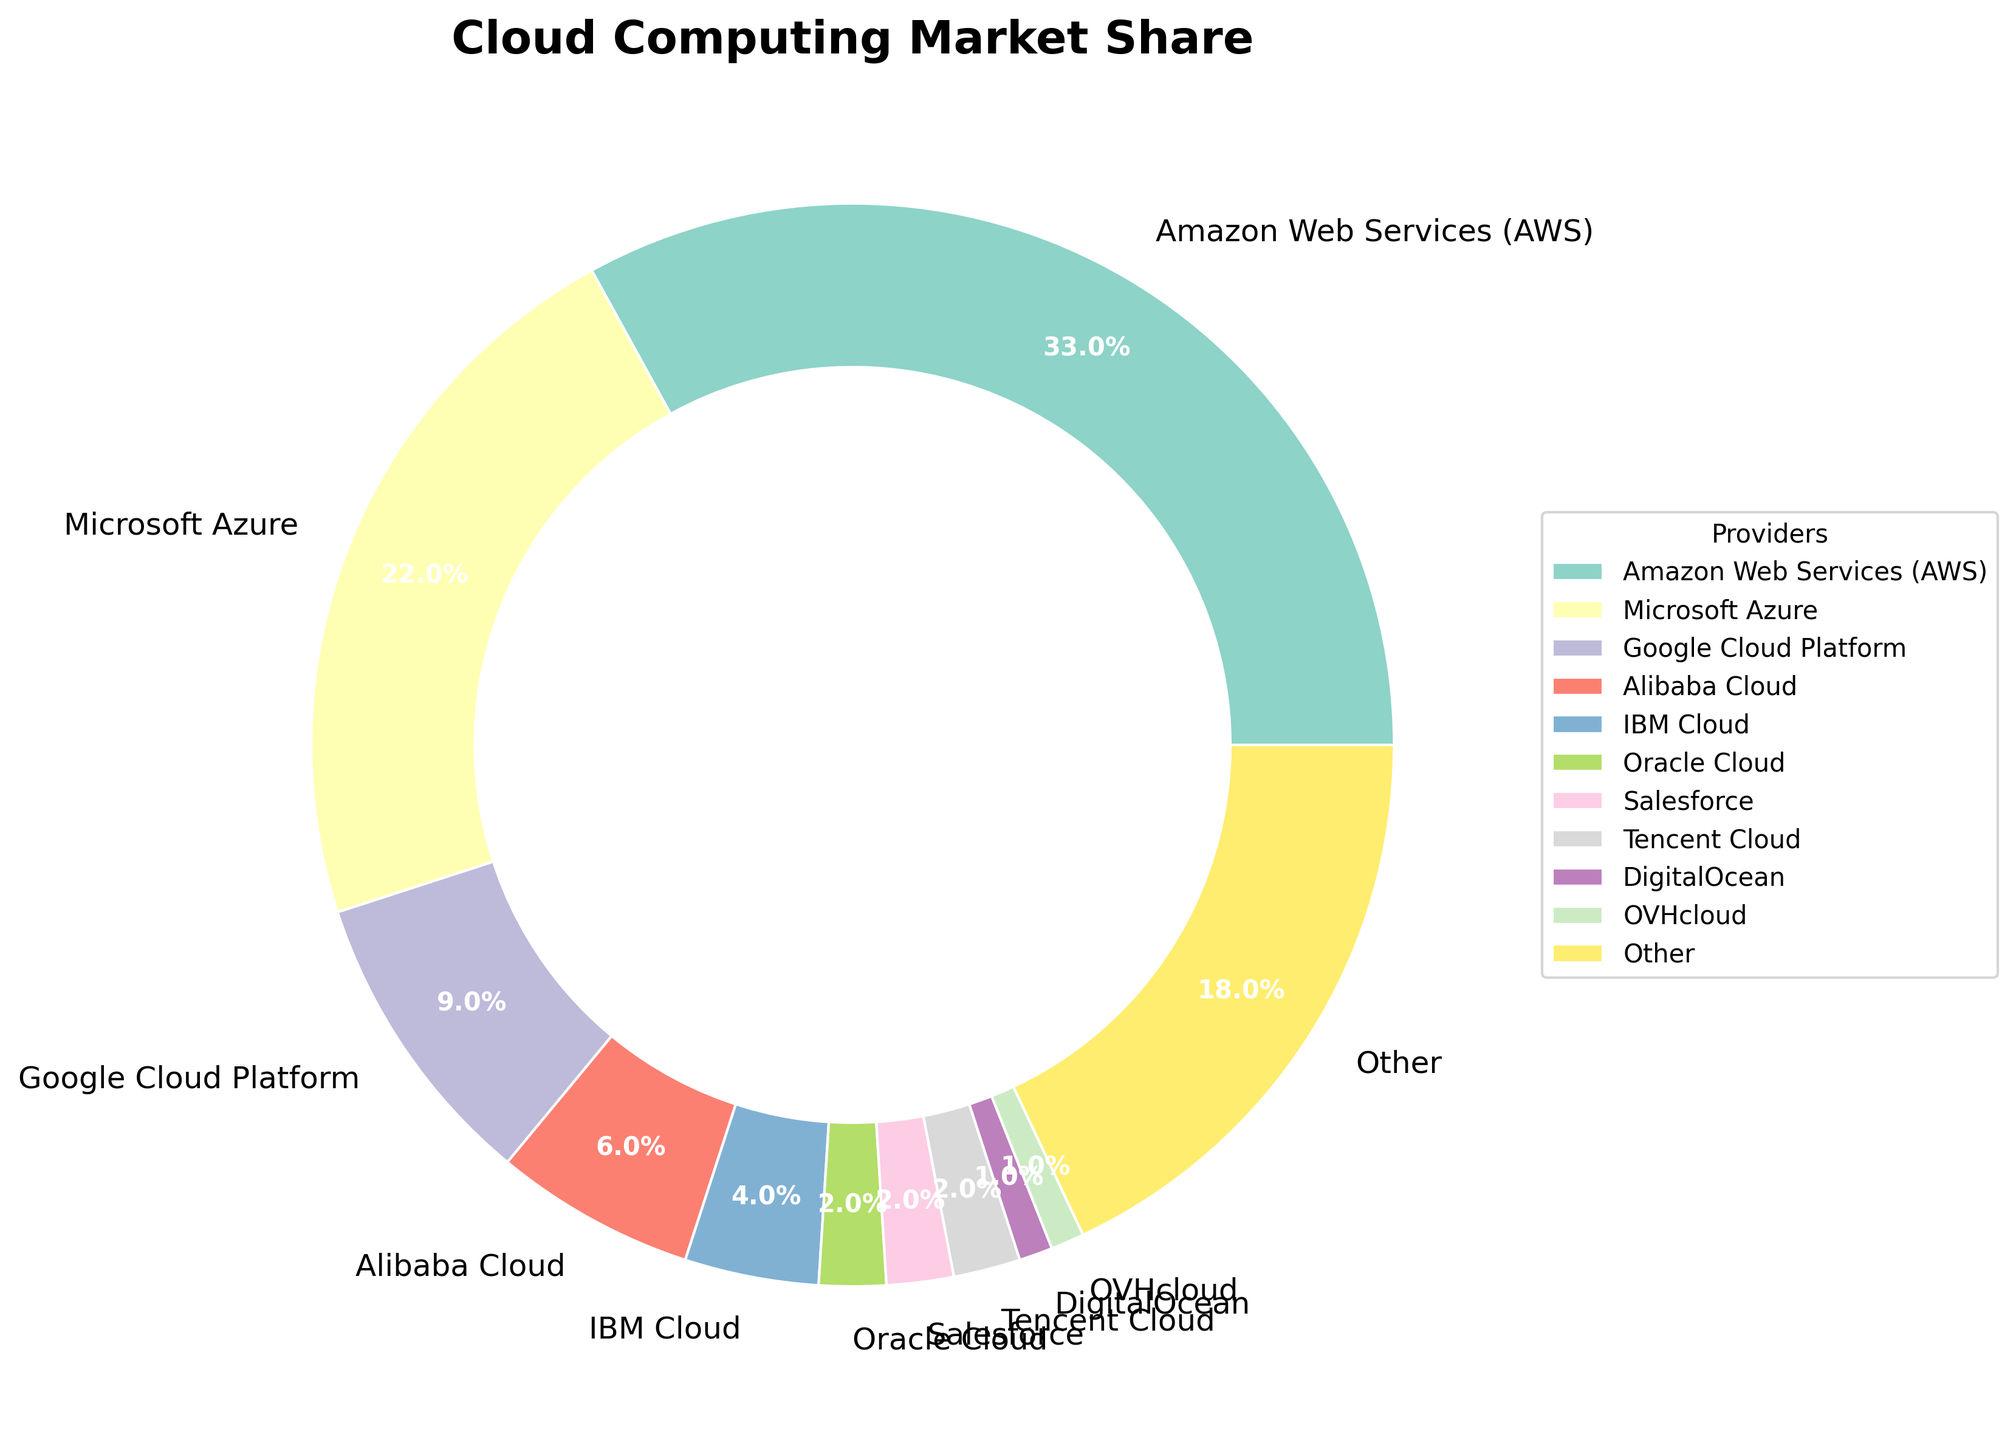What's the combined market share of AWS and Azure? AWS has a market share of 33% and Azure has 22%. To find the combined market share, add 33% and 22%: 33 + 22 = 55
Answer: 55% Between Google Cloud Platform and IBM Cloud, which provider has a larger market share and by how much? Google Cloud Platform has a market share of 9%, while IBM Cloud has 4%. The difference is 9 - 4 = 5. Therefore, Google Cloud Platform has a 5% larger market share than IBM Cloud.
Answer: Google Cloud Platform by 5% What percentage of the market share is held by providers with less than 5% individually? Add the market shares of Alibaba Cloud (6%), IBM Cloud (4%), Oracle Cloud (2%), Salesforce (2%), Tencent Cloud (2%), DigitalOcean (1%), and OVHcloud (1%). Only IBM Cloud, Oracle Cloud, Salesforce, Tencent Cloud, DigitalOcean, and OVHcloud have less than 5% each: 4 + 2 + 2 + 2 + 1 + 1 = 12
Answer: 12% Which provider has the smallest market share and what is its percentage? DigitalOcean and OVHcloud each have the smallest market share, at 1% each.
Answer: DigitalOcean and OVHcloud, 1% How much greater is AWS's market share compared to Alibaba Cloud's? AWS has a market share of 33% and Alibaba Cloud has 6%. The difference is 33 - 6 = 27
Answer: 27% What is the total market share of "Other" providers, and how does it compare to the market share of AWS? "Other" providers have a market share of 18%. AWS has a market share of 33%, so AWS surpasses "Other" providers by 33 - 18 = 15
Answer: 18%, AWS is greater by 15% If the providers with more than 5% market share are considered major providers, what percentage of the market do they occupy collectively? The providers with more than 5% market share are AWS (33%), Azure (22%), and Alibaba Cloud (6%). Add their market shares: 33 + 22 + 6 = 61
Answer: 61% What proportion of the market do Google Cloud Platform, Salesforce, and Tencent Cloud together hold? Google Cloud Platform (9%), Salesforce (2%), and Tencent Cloud (2%) together hold: 9 + 2 + 2 = 13
Answer: 13% Given the visual representation, which section of the pie chart is represented by the largest wedge and how can you identify it? The largest wedge visually represents AWS. This can be identified by locating the largest section of the pie chart, which corresponds to the 33% market share marked by "Amazon Web Services (AWS)".
Answer: AWS Do IBM Cloud and Oracle Cloud together have a larger or smaller market share compared to Google Cloud Platform? IBM Cloud (4%) and Oracle Cloud (2%) together have 4 + 2 = 6% market share. Google Cloud Platform has 9%. Thus, IBM Cloud and Oracle Cloud together have a smaller market share compared to Google Cloud Platform.
Answer: Smaller 